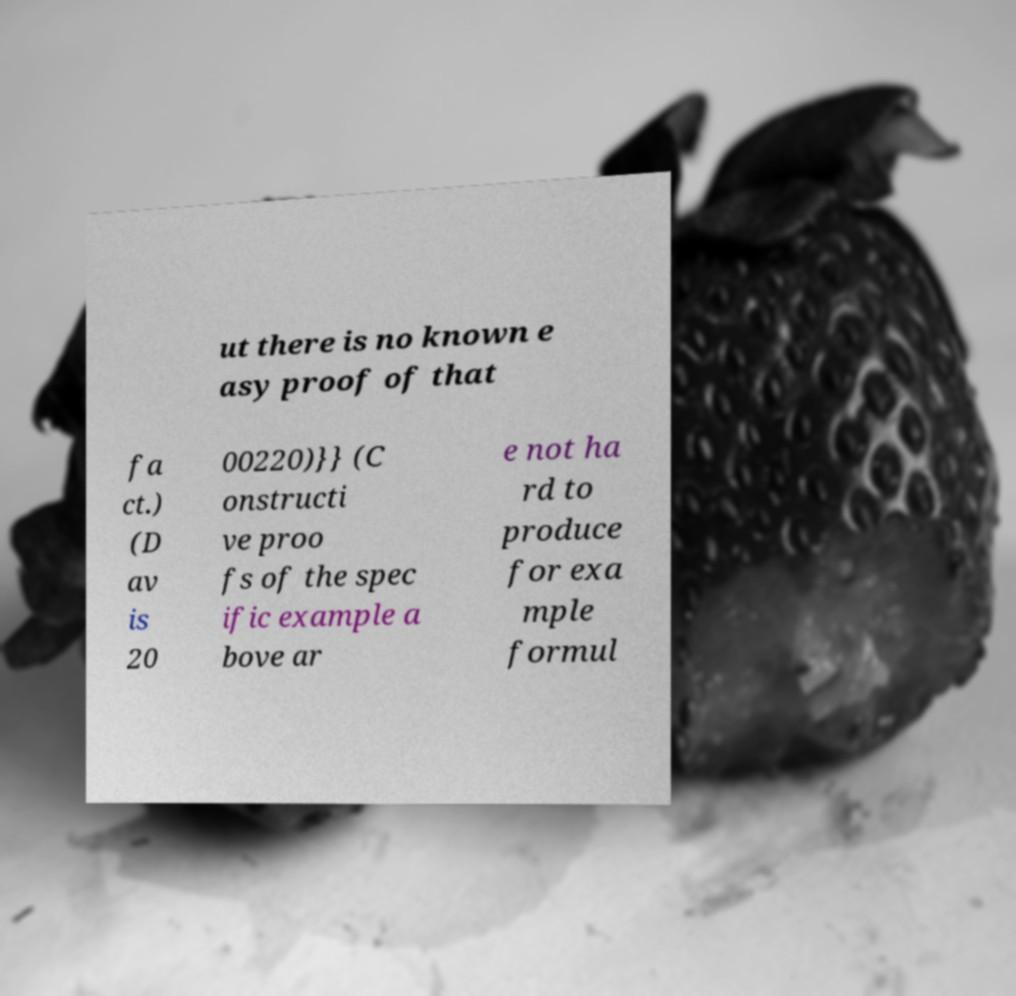Please identify and transcribe the text found in this image. ut there is no known e asy proof of that fa ct.) (D av is 20 00220)}} (C onstructi ve proo fs of the spec ific example a bove ar e not ha rd to produce for exa mple formul 